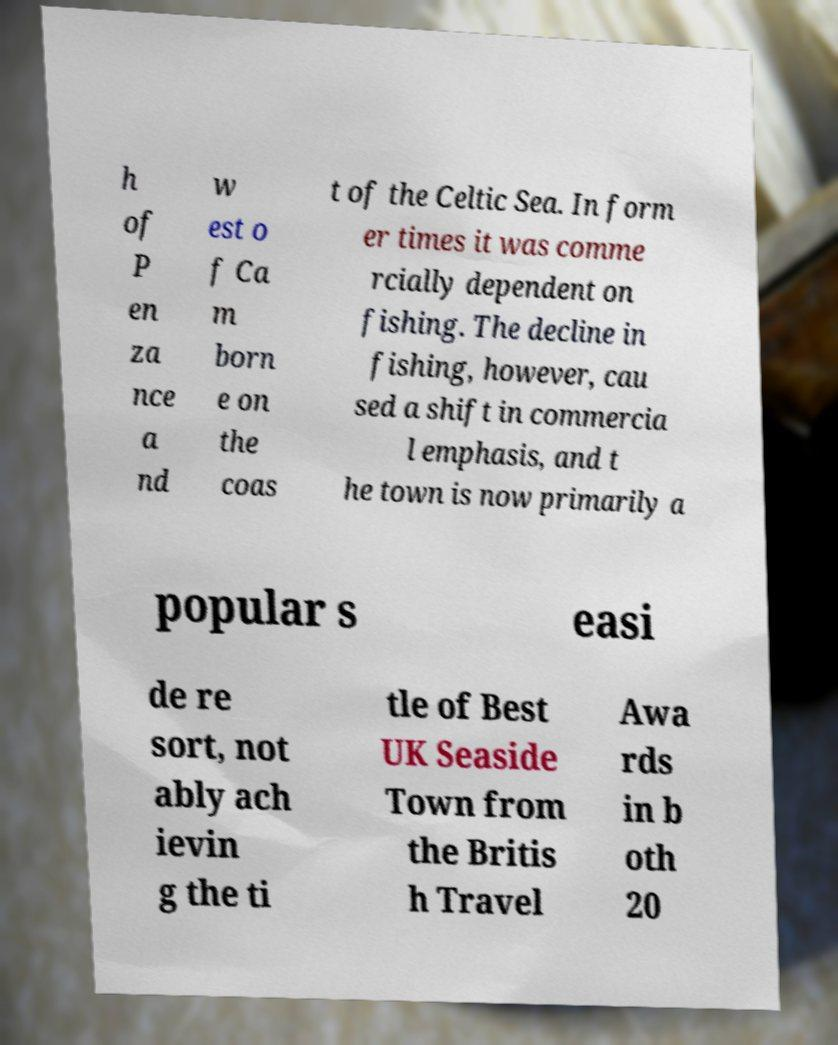What messages or text are displayed in this image? I need them in a readable, typed format. h of P en za nce a nd w est o f Ca m born e on the coas t of the Celtic Sea. In form er times it was comme rcially dependent on fishing. The decline in fishing, however, cau sed a shift in commercia l emphasis, and t he town is now primarily a popular s easi de re sort, not ably ach ievin g the ti tle of Best UK Seaside Town from the Britis h Travel Awa rds in b oth 20 